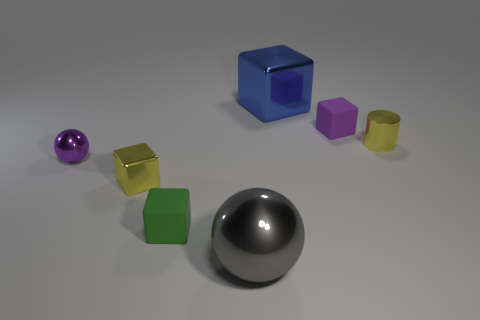The big metal cube has what color?
Offer a very short reply. Blue. How many metal balls are to the left of the small cube that is on the left side of the green thing?
Your answer should be very brief. 1. Is there a small yellow metallic thing that is right of the metal block left of the big blue thing?
Provide a short and direct response. Yes. Are there any small green matte objects to the right of the big gray metal thing?
Offer a very short reply. No. Is the shape of the big metallic object in front of the small ball the same as  the purple rubber thing?
Your response must be concise. No. What number of small metallic things have the same shape as the large gray shiny thing?
Your answer should be compact. 1. Are there any big blocks made of the same material as the small cylinder?
Give a very brief answer. Yes. What is the material of the tiny yellow block that is on the left side of the big metal block behind the gray sphere?
Offer a very short reply. Metal. How big is the matte object that is behind the tiny green rubber object?
Ensure brevity in your answer.  Small. There is a big shiny block; does it have the same color as the sphere that is behind the gray object?
Give a very brief answer. No. 